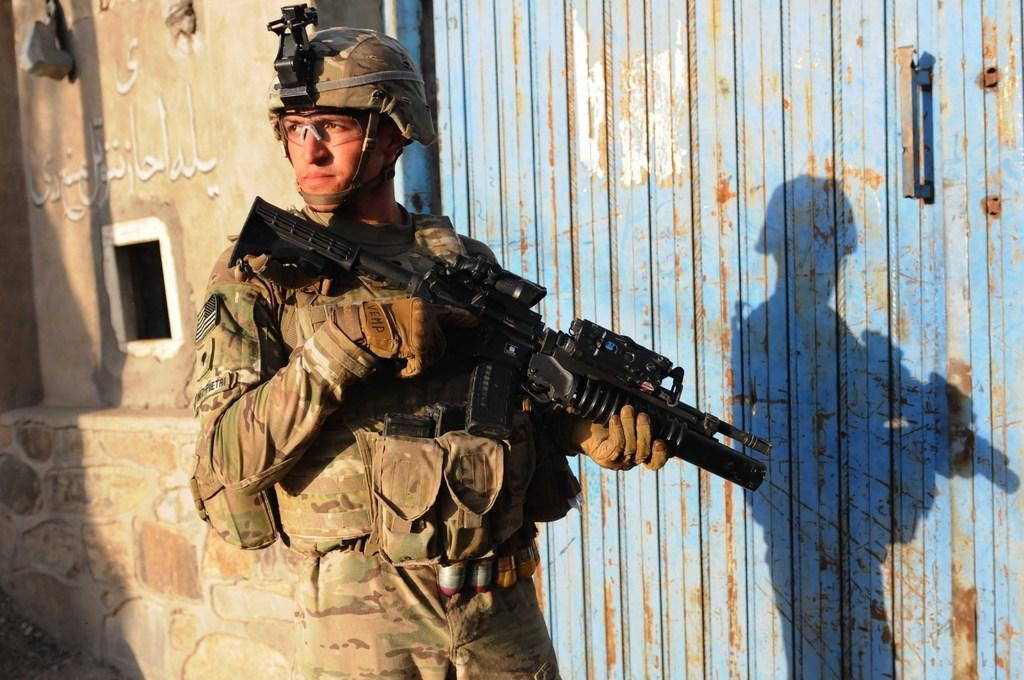What is the soldier in the image holding? The soldier is holding a gun in the image. Where is the soldier located in the image? The soldier is in the foreground area of the image. What can be seen in the background of the image? There appears to be a building in the background of the image. What type of spark can be seen coming from the soldier's gun in the image? There is no spark visible coming from the soldier's gun in the image. 